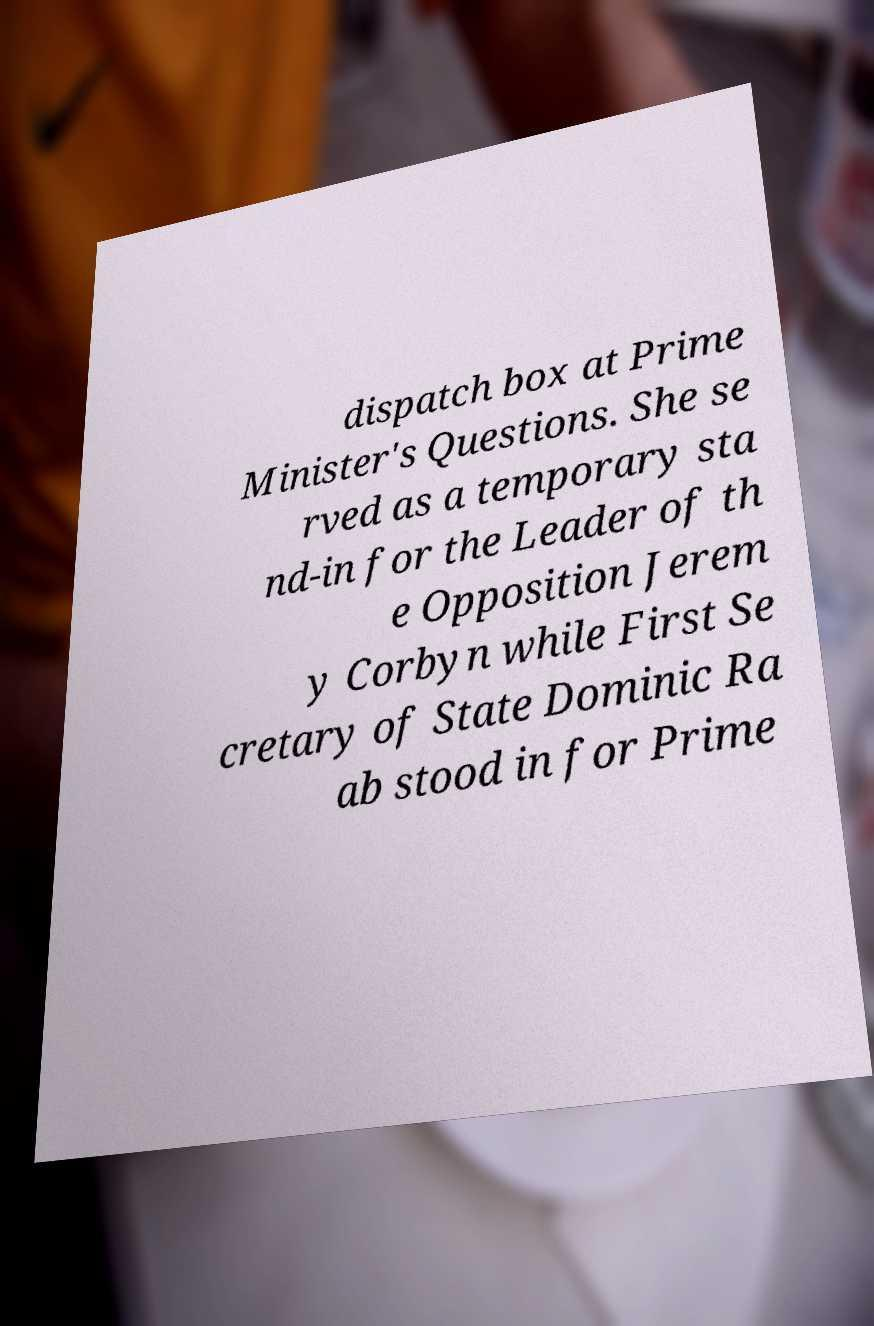Could you assist in decoding the text presented in this image and type it out clearly? dispatch box at Prime Minister's Questions. She se rved as a temporary sta nd-in for the Leader of th e Opposition Jerem y Corbyn while First Se cretary of State Dominic Ra ab stood in for Prime 